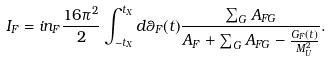<formula> <loc_0><loc_0><loc_500><loc_500>I _ { F } = i n _ { F } \frac { 1 6 \pi ^ { 2 } } { 2 } \int _ { - t _ { X } } ^ { t _ { X } } d \theta _ { F } ( t ) \frac { \sum _ { G } A _ { F G } } { A _ { F } + { \sum _ { G } A _ { F G } - \frac { G _ { F } ( t ) } { M _ { U } ^ { 2 } } } } .</formula> 